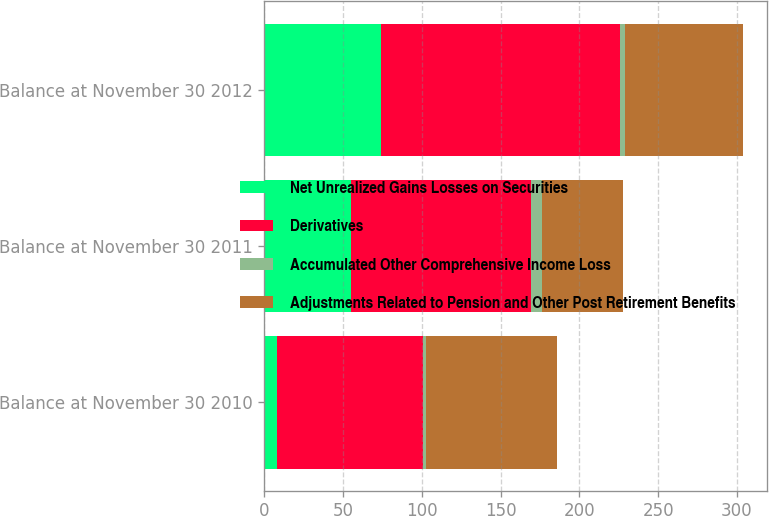Convert chart to OTSL. <chart><loc_0><loc_0><loc_500><loc_500><stacked_bar_chart><ecel><fcel>Balance at November 30 2010<fcel>Balance at November 30 2011<fcel>Balance at November 30 2012<nl><fcel>Net Unrealized Gains Losses on Securities<fcel>8<fcel>55<fcel>74<nl><fcel>Derivatives<fcel>93<fcel>114<fcel>152<nl><fcel>Accumulated Other Comprehensive Income Loss<fcel>2<fcel>7<fcel>3<nl><fcel>Adjustments Related to Pension and Other Post Retirement Benefits<fcel>83<fcel>52<fcel>75<nl></chart> 